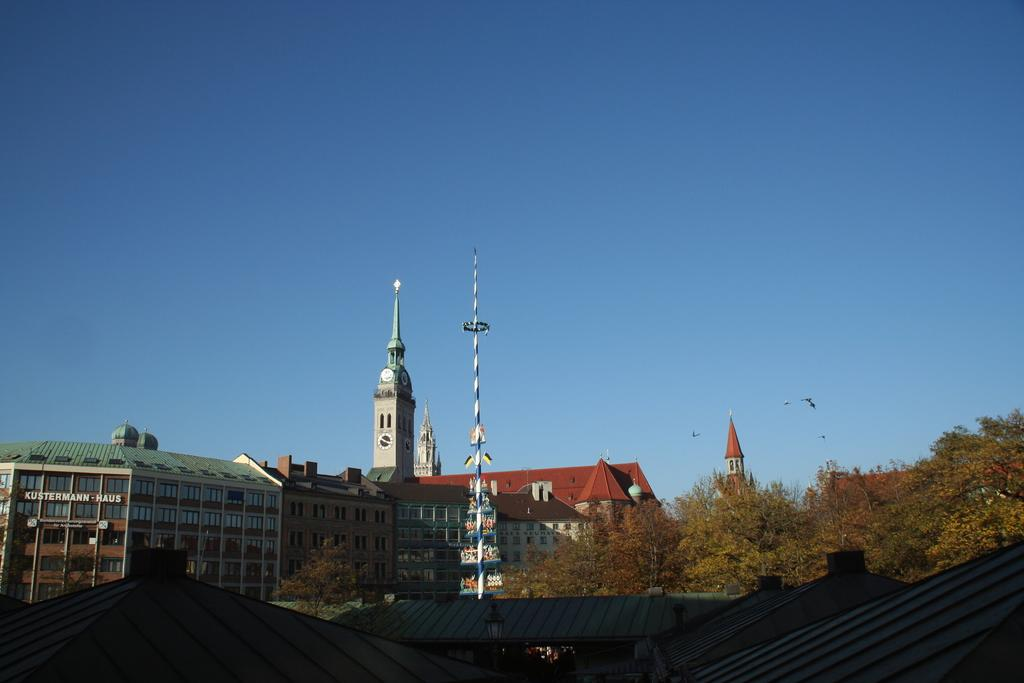What is the color of the building in the image? The building in the image is brown. What type of windows does the building have? The building has many glass windows. What architectural feature is present on the building? There is a clock tower on the building. What can be seen at the front bottom side of the image? There are sheds in the front bottom side of the image. What type of vegetation is present in the image? There are brown color trees in the image. Can you see any chalk drawings on the ground near the trees in the image? There is no chalk or chalk drawings present in the image. Is there a donkey grazing near the trees in the image? There is no donkey present in the image. 